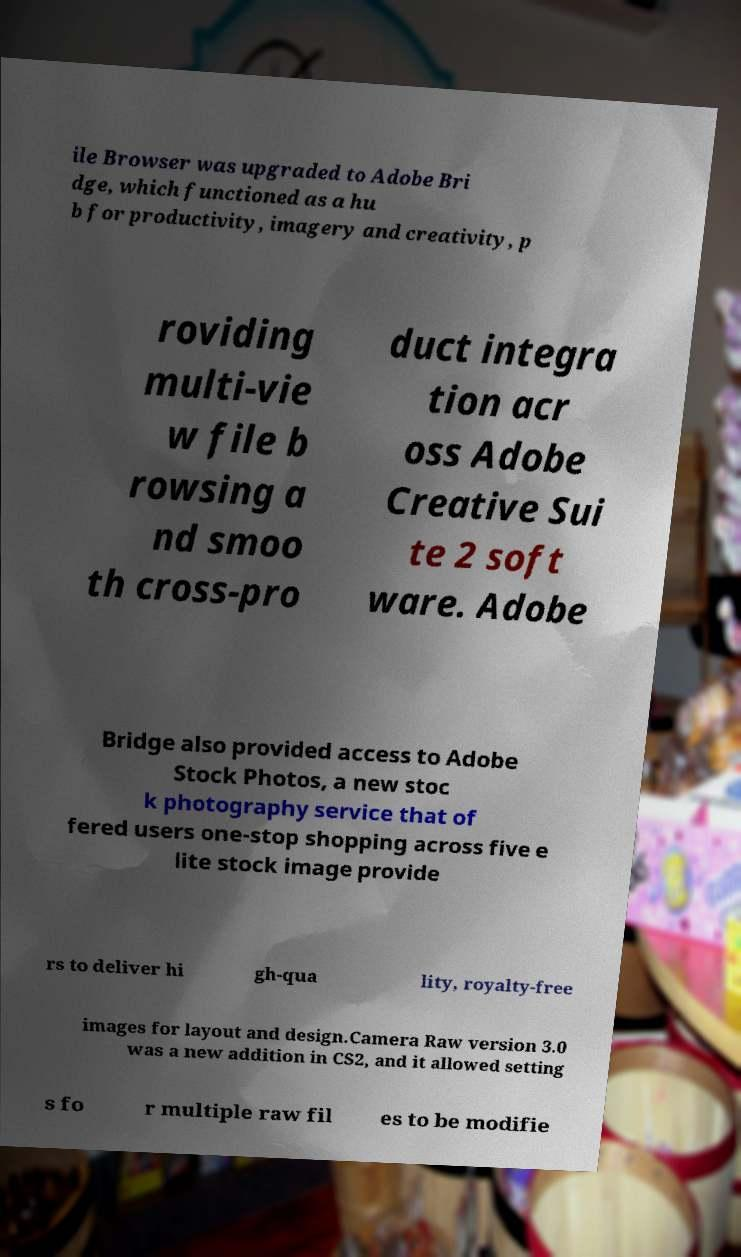For documentation purposes, I need the text within this image transcribed. Could you provide that? ile Browser was upgraded to Adobe Bri dge, which functioned as a hu b for productivity, imagery and creativity, p roviding multi-vie w file b rowsing a nd smoo th cross-pro duct integra tion acr oss Adobe Creative Sui te 2 soft ware. Adobe Bridge also provided access to Adobe Stock Photos, a new stoc k photography service that of fered users one-stop shopping across five e lite stock image provide rs to deliver hi gh-qua lity, royalty-free images for layout and design.Camera Raw version 3.0 was a new addition in CS2, and it allowed setting s fo r multiple raw fil es to be modifie 